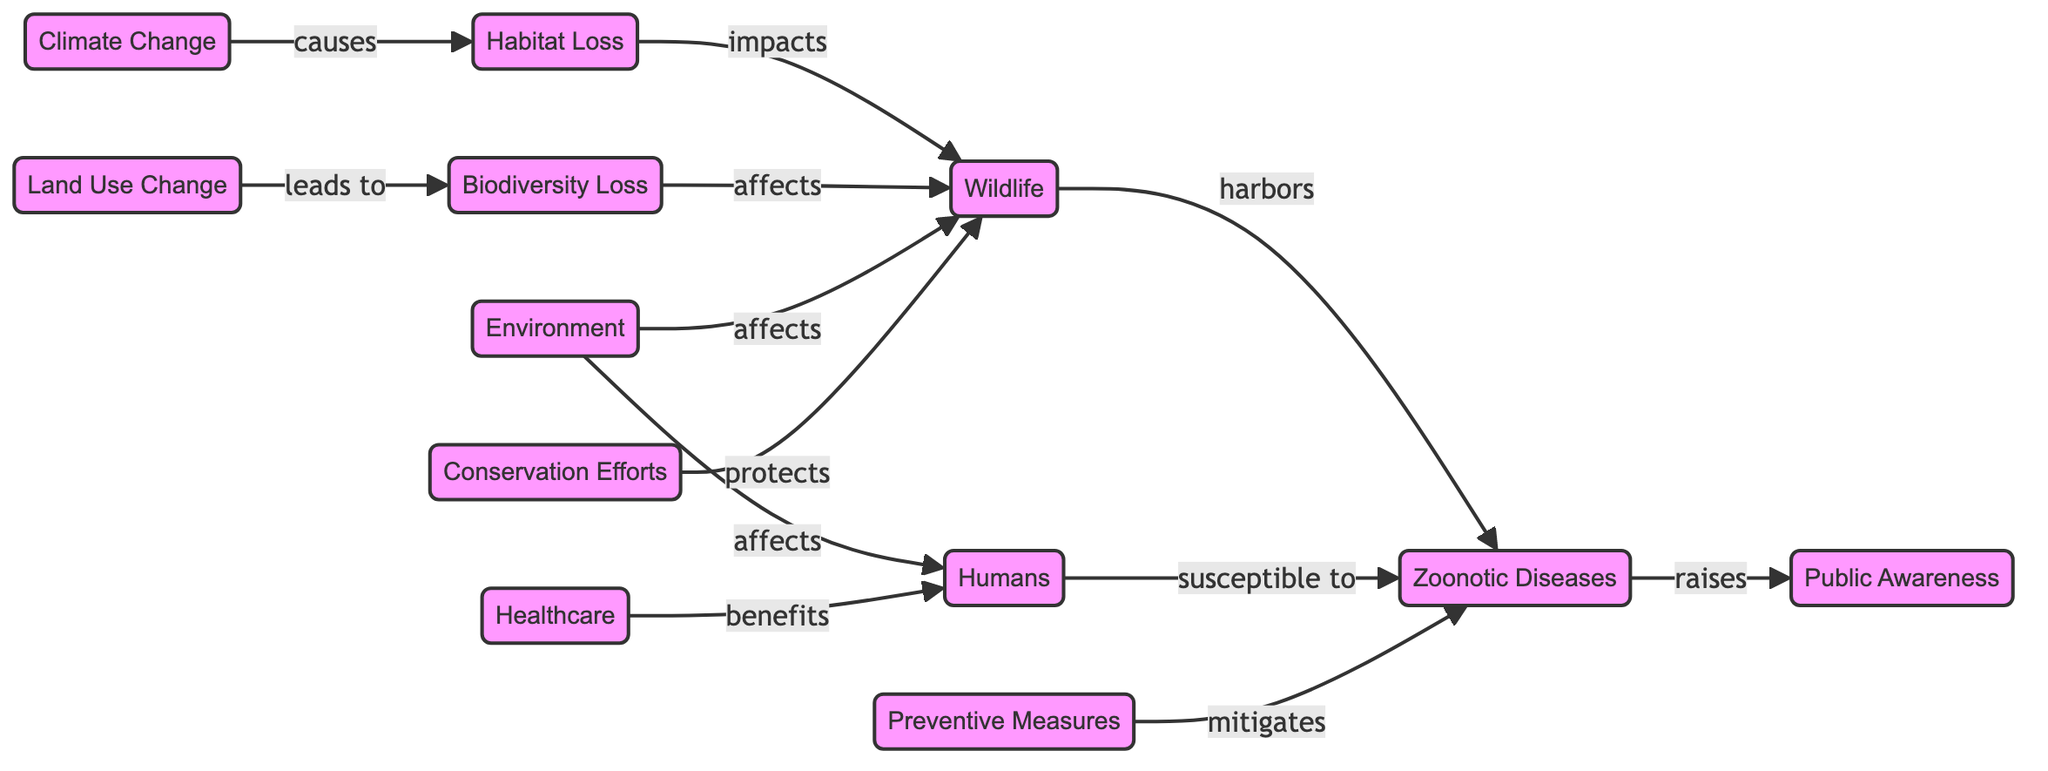What are the three main nodes in the diagram? The diagram includes nodes for Wildlife, Humans, and Environment, which are central to the connections depicted. These nodes interact with other factors that relate to zoonotic diseases and climate change.
Answer: Wildlife, Humans, Environment How many nodes are present in the diagram? Upon examining the diagram, we count a total of 12 distinct nodes indicating the various factors that impact or are impacted by zoonotic diseases and climate change.
Answer: 12 What relationship exists between Climate Change and Habitat Loss? The diagram illustrates that Climate Change directly causes Habitat Loss, indicating a clear causal relationship that highlights how climate issues impact wildlife spaces.
Answer: causes Which factors increase Public Awareness according to the diagram? The diagram shows that Zoonotic Diseases raise Public Awareness, suggesting that outbreaks or concerns regarding diseases transmitted from wildlife to humans heighten awareness around these issues.
Answer: Zoonotic Diseases How do Conservation Efforts affect Wildlife? The flow in the diagram indicates that Conservation Efforts protect Wildlife, establishing a positive link where conservation initiatives help safeguard animal populations and their habitats.
Answer: protects If Land Use Change leads to Biodiversity Loss, what is the subsequent effect on Wildlife? The sequence in the diagram shows that Biodiversity Loss affects Wildlife, meaning that as land use changes impact biodiversity negatively, wildlife populations are subsequently impacted as well.
Answer: affects What is the relationship between Preventive Measures and Zoonotic Diseases? The diagram specifies that Preventive Measures mitigate Zoonotic Diseases, showing that interventions can reduce the frequency or impact of diseases transferred from animals to humans.
Answer: mitigates What do Healthcare efforts benefit according to the diagram? The connection in the diagram indicates that Healthcare benefits Humans, emphasizing the role of healthcare systems in addressing health issues related to zoonotic diseases and overall public health.
Answer: Humans How does the Environment affect Humans in this diagram? The diagram presents a direct relationship, indicating that the Environment affects Humans, which could refer to how environmental changes lead to health issues or disease exposure.
Answer: affects 